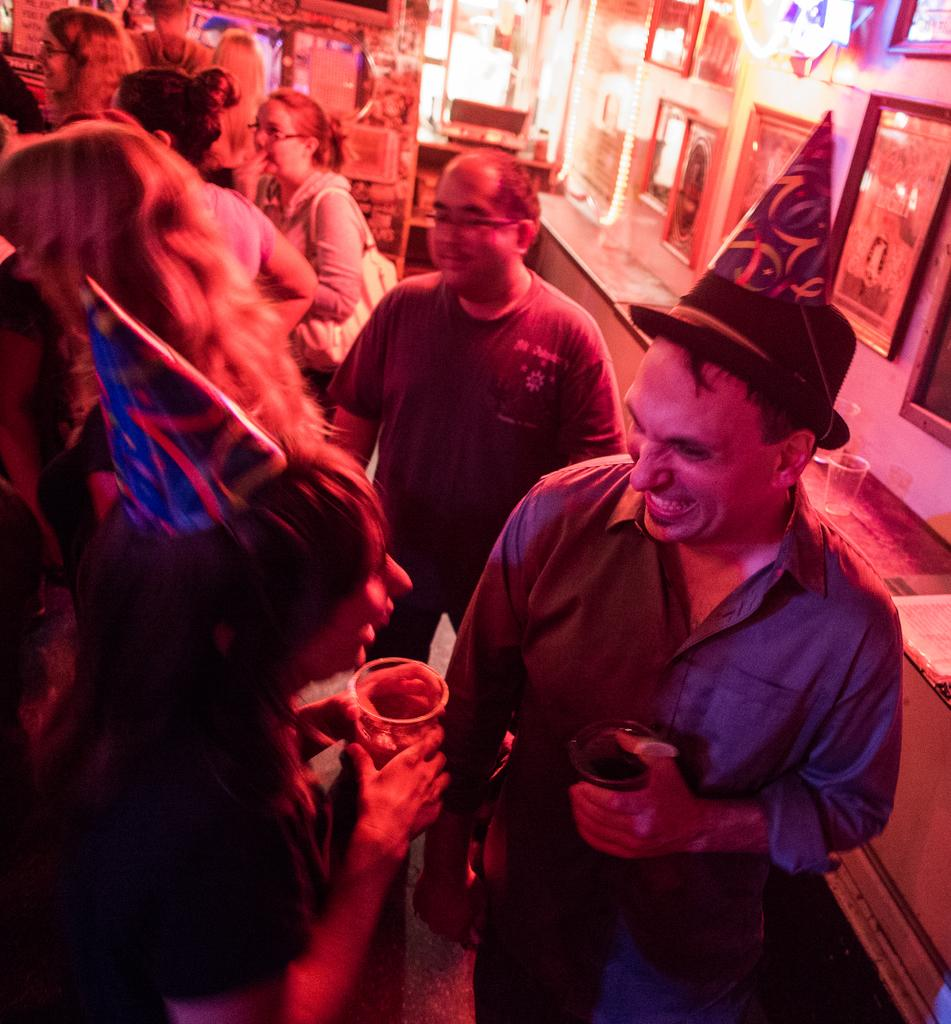What is happening in the image? There are people standing in the image. What are the people holding? The people are holding objects. What can be seen on the wall in the image? There are frames on the wall in the image. What religion is being practiced in the image? There is no indication of any religious practice in the image. What point is being made by the people in the image? The image does not convey any specific point or message. 